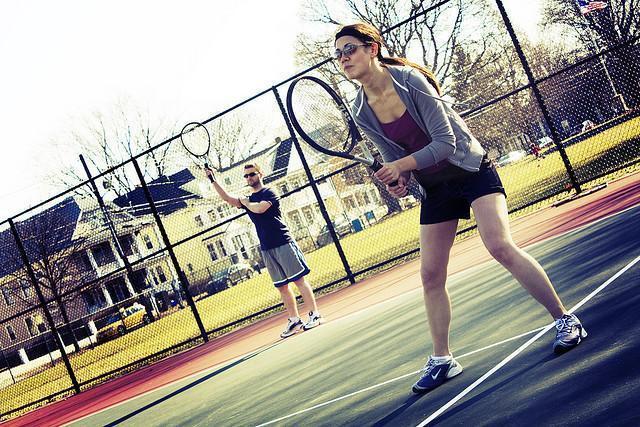What configuration of tennis is being played here?
Indicate the correct response by choosing from the four available options to answer the question.
Options: Racial, swoop hawk, singles, doubles. Doubles. 